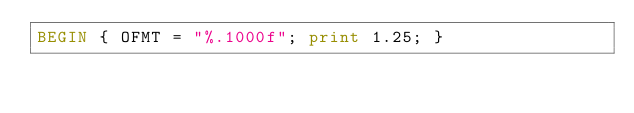<code> <loc_0><loc_0><loc_500><loc_500><_Awk_>BEGIN { OFMT = "%.1000f"; print 1.25; }
</code> 